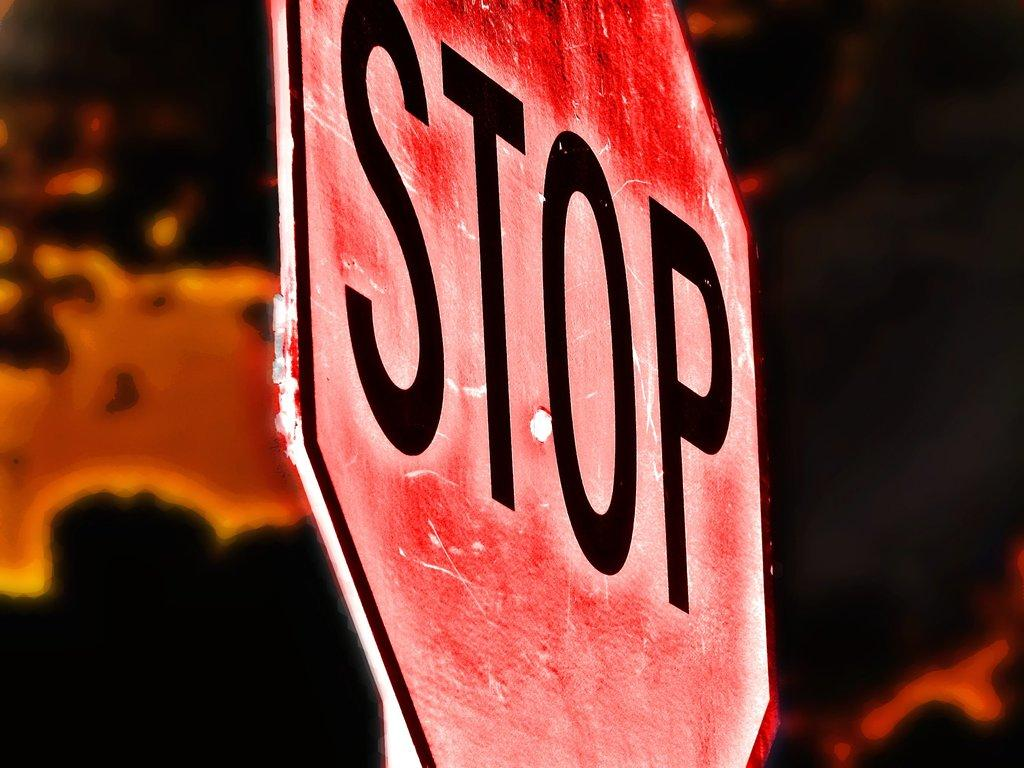<image>
Relay a brief, clear account of the picture shown. A red octagon sign with the letters STOP in Black on it. 